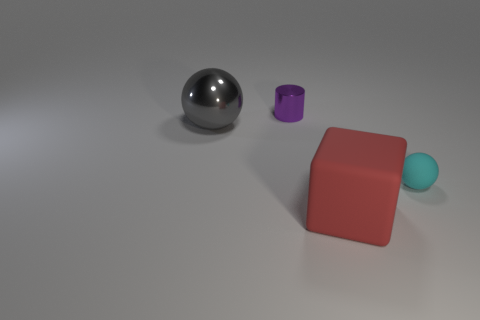How many large gray shiny things are the same shape as the large matte thing?
Make the answer very short. 0. What material is the ball that is right of the metal sphere?
Offer a terse response. Rubber. There is a thing that is right of the big block; is it the same shape as the small purple thing?
Give a very brief answer. No. Are there any red metal cubes of the same size as the red matte cube?
Your answer should be very brief. No. Does the tiny cyan object have the same shape as the large thing that is to the left of the cube?
Keep it short and to the point. Yes. Are there fewer large gray balls in front of the cyan ball than tiny red rubber blocks?
Offer a very short reply. No. Does the cyan rubber object have the same shape as the large shiny object?
Your answer should be very brief. Yes. The red object that is the same material as the cyan ball is what size?
Make the answer very short. Large. Are there fewer small yellow blocks than things?
Your answer should be very brief. Yes. How many big objects are either purple rubber cubes or red blocks?
Give a very brief answer. 1. 